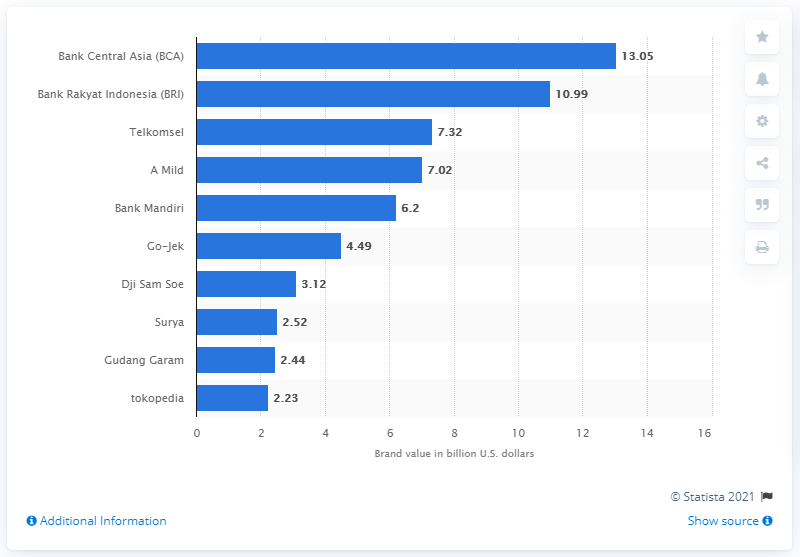What information does this chart present and from which year is the data? The chart presents the brand values of various Indonesian companies in billion U.S. dollars. The data is sourced from Statista 2021. 